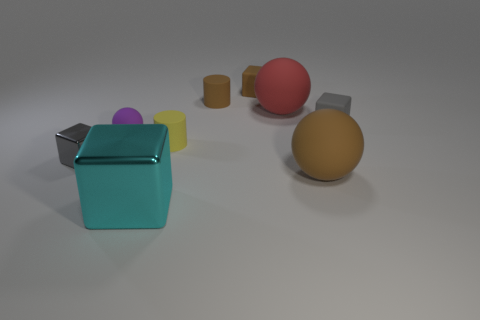Subtract 2 cubes. How many cubes are left? 2 Subtract all green cubes. Subtract all red balls. How many cubes are left? 4 Add 1 cyan matte cylinders. How many objects exist? 10 Subtract all cubes. How many objects are left? 5 Subtract all red rubber spheres. Subtract all metal objects. How many objects are left? 6 Add 6 small rubber spheres. How many small rubber spheres are left? 7 Add 6 gray rubber spheres. How many gray rubber spheres exist? 6 Subtract 1 purple balls. How many objects are left? 8 